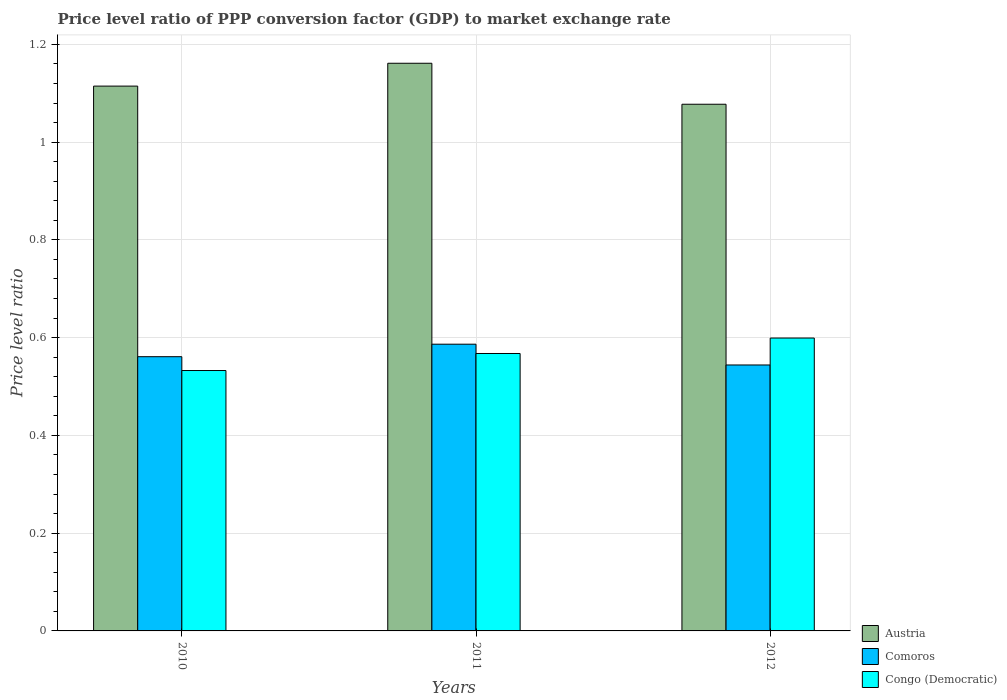How many different coloured bars are there?
Your answer should be compact. 3. Are the number of bars per tick equal to the number of legend labels?
Keep it short and to the point. Yes. Are the number of bars on each tick of the X-axis equal?
Provide a succinct answer. Yes. What is the label of the 1st group of bars from the left?
Offer a terse response. 2010. In how many cases, is the number of bars for a given year not equal to the number of legend labels?
Give a very brief answer. 0. What is the price level ratio in Congo (Democratic) in 2011?
Offer a very short reply. 0.57. Across all years, what is the maximum price level ratio in Austria?
Your answer should be compact. 1.16. Across all years, what is the minimum price level ratio in Comoros?
Your response must be concise. 0.54. In which year was the price level ratio in Austria maximum?
Your answer should be very brief. 2011. In which year was the price level ratio in Comoros minimum?
Offer a very short reply. 2012. What is the total price level ratio in Comoros in the graph?
Your response must be concise. 1.69. What is the difference between the price level ratio in Comoros in 2011 and that in 2012?
Keep it short and to the point. 0.04. What is the difference between the price level ratio in Austria in 2010 and the price level ratio in Comoros in 2012?
Keep it short and to the point. 0.57. What is the average price level ratio in Comoros per year?
Ensure brevity in your answer.  0.56. In the year 2011, what is the difference between the price level ratio in Austria and price level ratio in Comoros?
Keep it short and to the point. 0.57. In how many years, is the price level ratio in Congo (Democratic) greater than 0.56?
Keep it short and to the point. 2. What is the ratio of the price level ratio in Comoros in 2010 to that in 2012?
Ensure brevity in your answer.  1.03. What is the difference between the highest and the second highest price level ratio in Austria?
Your answer should be compact. 0.05. What is the difference between the highest and the lowest price level ratio in Congo (Democratic)?
Ensure brevity in your answer.  0.07. Is the sum of the price level ratio in Congo (Democratic) in 2011 and 2012 greater than the maximum price level ratio in Comoros across all years?
Provide a succinct answer. Yes. What does the 2nd bar from the left in 2010 represents?
Make the answer very short. Comoros. What does the 2nd bar from the right in 2011 represents?
Your answer should be compact. Comoros. Is it the case that in every year, the sum of the price level ratio in Austria and price level ratio in Congo (Democratic) is greater than the price level ratio in Comoros?
Offer a terse response. Yes. How many bars are there?
Your response must be concise. 9. What is the difference between two consecutive major ticks on the Y-axis?
Offer a very short reply. 0.2. How many legend labels are there?
Keep it short and to the point. 3. What is the title of the graph?
Provide a succinct answer. Price level ratio of PPP conversion factor (GDP) to market exchange rate. Does "Rwanda" appear as one of the legend labels in the graph?
Offer a terse response. No. What is the label or title of the Y-axis?
Your answer should be very brief. Price level ratio. What is the Price level ratio of Austria in 2010?
Your answer should be compact. 1.11. What is the Price level ratio in Comoros in 2010?
Make the answer very short. 0.56. What is the Price level ratio of Congo (Democratic) in 2010?
Make the answer very short. 0.53. What is the Price level ratio in Austria in 2011?
Give a very brief answer. 1.16. What is the Price level ratio in Comoros in 2011?
Your answer should be very brief. 0.59. What is the Price level ratio of Congo (Democratic) in 2011?
Offer a terse response. 0.57. What is the Price level ratio in Austria in 2012?
Ensure brevity in your answer.  1.08. What is the Price level ratio of Comoros in 2012?
Provide a succinct answer. 0.54. What is the Price level ratio of Congo (Democratic) in 2012?
Offer a very short reply. 0.6. Across all years, what is the maximum Price level ratio of Austria?
Make the answer very short. 1.16. Across all years, what is the maximum Price level ratio in Comoros?
Your answer should be compact. 0.59. Across all years, what is the maximum Price level ratio in Congo (Democratic)?
Offer a very short reply. 0.6. Across all years, what is the minimum Price level ratio of Austria?
Ensure brevity in your answer.  1.08. Across all years, what is the minimum Price level ratio of Comoros?
Offer a terse response. 0.54. Across all years, what is the minimum Price level ratio in Congo (Democratic)?
Provide a short and direct response. 0.53. What is the total Price level ratio in Austria in the graph?
Provide a short and direct response. 3.35. What is the total Price level ratio of Comoros in the graph?
Give a very brief answer. 1.69. What is the total Price level ratio in Congo (Democratic) in the graph?
Make the answer very short. 1.7. What is the difference between the Price level ratio in Austria in 2010 and that in 2011?
Keep it short and to the point. -0.05. What is the difference between the Price level ratio of Comoros in 2010 and that in 2011?
Your answer should be very brief. -0.03. What is the difference between the Price level ratio of Congo (Democratic) in 2010 and that in 2011?
Ensure brevity in your answer.  -0.03. What is the difference between the Price level ratio in Austria in 2010 and that in 2012?
Your answer should be compact. 0.04. What is the difference between the Price level ratio in Comoros in 2010 and that in 2012?
Provide a short and direct response. 0.02. What is the difference between the Price level ratio of Congo (Democratic) in 2010 and that in 2012?
Offer a very short reply. -0.07. What is the difference between the Price level ratio in Austria in 2011 and that in 2012?
Offer a terse response. 0.08. What is the difference between the Price level ratio in Comoros in 2011 and that in 2012?
Provide a short and direct response. 0.04. What is the difference between the Price level ratio in Congo (Democratic) in 2011 and that in 2012?
Keep it short and to the point. -0.03. What is the difference between the Price level ratio in Austria in 2010 and the Price level ratio in Comoros in 2011?
Ensure brevity in your answer.  0.53. What is the difference between the Price level ratio in Austria in 2010 and the Price level ratio in Congo (Democratic) in 2011?
Offer a terse response. 0.55. What is the difference between the Price level ratio of Comoros in 2010 and the Price level ratio of Congo (Democratic) in 2011?
Give a very brief answer. -0.01. What is the difference between the Price level ratio of Austria in 2010 and the Price level ratio of Comoros in 2012?
Your answer should be compact. 0.57. What is the difference between the Price level ratio of Austria in 2010 and the Price level ratio of Congo (Democratic) in 2012?
Keep it short and to the point. 0.52. What is the difference between the Price level ratio of Comoros in 2010 and the Price level ratio of Congo (Democratic) in 2012?
Provide a succinct answer. -0.04. What is the difference between the Price level ratio of Austria in 2011 and the Price level ratio of Comoros in 2012?
Give a very brief answer. 0.62. What is the difference between the Price level ratio in Austria in 2011 and the Price level ratio in Congo (Democratic) in 2012?
Make the answer very short. 0.56. What is the difference between the Price level ratio in Comoros in 2011 and the Price level ratio in Congo (Democratic) in 2012?
Your answer should be compact. -0.01. What is the average Price level ratio in Austria per year?
Ensure brevity in your answer.  1.12. What is the average Price level ratio in Comoros per year?
Your answer should be very brief. 0.56. What is the average Price level ratio in Congo (Democratic) per year?
Your response must be concise. 0.57. In the year 2010, what is the difference between the Price level ratio in Austria and Price level ratio in Comoros?
Your answer should be compact. 0.55. In the year 2010, what is the difference between the Price level ratio of Austria and Price level ratio of Congo (Democratic)?
Keep it short and to the point. 0.58. In the year 2010, what is the difference between the Price level ratio of Comoros and Price level ratio of Congo (Democratic)?
Give a very brief answer. 0.03. In the year 2011, what is the difference between the Price level ratio in Austria and Price level ratio in Comoros?
Provide a short and direct response. 0.57. In the year 2011, what is the difference between the Price level ratio in Austria and Price level ratio in Congo (Democratic)?
Your answer should be compact. 0.59. In the year 2011, what is the difference between the Price level ratio in Comoros and Price level ratio in Congo (Democratic)?
Provide a short and direct response. 0.02. In the year 2012, what is the difference between the Price level ratio of Austria and Price level ratio of Comoros?
Offer a terse response. 0.53. In the year 2012, what is the difference between the Price level ratio in Austria and Price level ratio in Congo (Democratic)?
Offer a very short reply. 0.48. In the year 2012, what is the difference between the Price level ratio in Comoros and Price level ratio in Congo (Democratic)?
Offer a terse response. -0.06. What is the ratio of the Price level ratio of Austria in 2010 to that in 2011?
Offer a very short reply. 0.96. What is the ratio of the Price level ratio in Comoros in 2010 to that in 2011?
Keep it short and to the point. 0.96. What is the ratio of the Price level ratio of Congo (Democratic) in 2010 to that in 2011?
Provide a short and direct response. 0.94. What is the ratio of the Price level ratio in Austria in 2010 to that in 2012?
Keep it short and to the point. 1.03. What is the ratio of the Price level ratio in Comoros in 2010 to that in 2012?
Provide a succinct answer. 1.03. What is the ratio of the Price level ratio of Congo (Democratic) in 2010 to that in 2012?
Provide a succinct answer. 0.89. What is the ratio of the Price level ratio in Austria in 2011 to that in 2012?
Your answer should be very brief. 1.08. What is the ratio of the Price level ratio in Comoros in 2011 to that in 2012?
Offer a terse response. 1.08. What is the ratio of the Price level ratio of Congo (Democratic) in 2011 to that in 2012?
Your response must be concise. 0.95. What is the difference between the highest and the second highest Price level ratio of Austria?
Give a very brief answer. 0.05. What is the difference between the highest and the second highest Price level ratio in Comoros?
Make the answer very short. 0.03. What is the difference between the highest and the second highest Price level ratio in Congo (Democratic)?
Offer a very short reply. 0.03. What is the difference between the highest and the lowest Price level ratio of Austria?
Your response must be concise. 0.08. What is the difference between the highest and the lowest Price level ratio in Comoros?
Ensure brevity in your answer.  0.04. What is the difference between the highest and the lowest Price level ratio of Congo (Democratic)?
Your answer should be very brief. 0.07. 